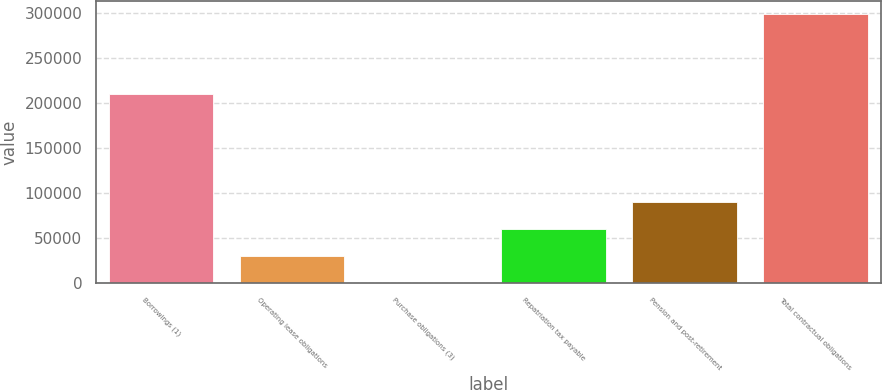Convert chart to OTSL. <chart><loc_0><loc_0><loc_500><loc_500><bar_chart><fcel>Borrowings (1)<fcel>Operating lease obligations<fcel>Purchase obligations (3)<fcel>Repatriation tax payable<fcel>Pension and post-retirement<fcel>Total contractual obligations<nl><fcel>210025<fcel>30263<fcel>428<fcel>60098<fcel>89933<fcel>298778<nl></chart> 